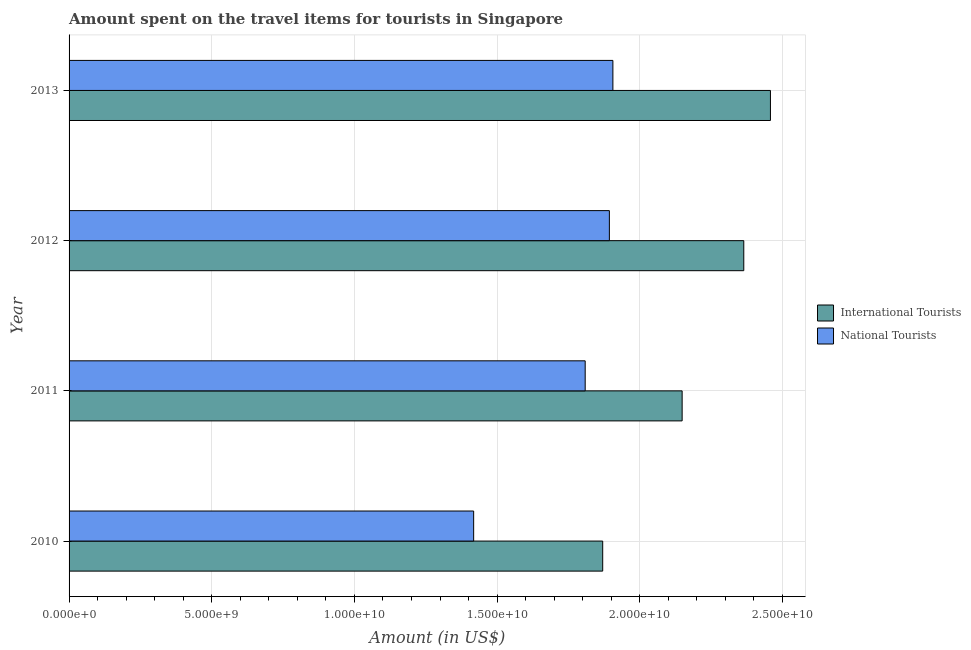How many different coloured bars are there?
Offer a very short reply. 2. How many groups of bars are there?
Offer a very short reply. 4. How many bars are there on the 1st tick from the top?
Ensure brevity in your answer.  2. How many bars are there on the 3rd tick from the bottom?
Give a very brief answer. 2. What is the label of the 2nd group of bars from the top?
Offer a terse response. 2012. What is the amount spent on travel items of international tourists in 2013?
Give a very brief answer. 2.46e+1. Across all years, what is the maximum amount spent on travel items of national tourists?
Your response must be concise. 1.91e+1. Across all years, what is the minimum amount spent on travel items of national tourists?
Ensure brevity in your answer.  1.42e+1. In which year was the amount spent on travel items of international tourists maximum?
Ensure brevity in your answer.  2013. In which year was the amount spent on travel items of international tourists minimum?
Provide a succinct answer. 2010. What is the total amount spent on travel items of national tourists in the graph?
Offer a terse response. 7.03e+1. What is the difference between the amount spent on travel items of national tourists in 2010 and that in 2011?
Keep it short and to the point. -3.91e+09. What is the difference between the amount spent on travel items of international tourists in 2012 and the amount spent on travel items of national tourists in 2010?
Your response must be concise. 9.47e+09. What is the average amount spent on travel items of international tourists per year?
Your response must be concise. 2.21e+1. In the year 2013, what is the difference between the amount spent on travel items of national tourists and amount spent on travel items of international tourists?
Provide a succinct answer. -5.52e+09. What is the ratio of the amount spent on travel items of national tourists in 2011 to that in 2012?
Offer a very short reply. 0.95. Is the amount spent on travel items of national tourists in 2010 less than that in 2013?
Your answer should be very brief. Yes. What is the difference between the highest and the second highest amount spent on travel items of national tourists?
Provide a short and direct response. 1.23e+08. What is the difference between the highest and the lowest amount spent on travel items of international tourists?
Provide a succinct answer. 5.88e+09. In how many years, is the amount spent on travel items of national tourists greater than the average amount spent on travel items of national tourists taken over all years?
Provide a succinct answer. 3. Is the sum of the amount spent on travel items of international tourists in 2010 and 2011 greater than the maximum amount spent on travel items of national tourists across all years?
Offer a very short reply. Yes. What does the 2nd bar from the top in 2010 represents?
Provide a short and direct response. International Tourists. What does the 1st bar from the bottom in 2011 represents?
Make the answer very short. International Tourists. How many years are there in the graph?
Provide a succinct answer. 4. Are the values on the major ticks of X-axis written in scientific E-notation?
Ensure brevity in your answer.  Yes. Does the graph contain any zero values?
Offer a terse response. No. Does the graph contain grids?
Offer a very short reply. Yes. How many legend labels are there?
Ensure brevity in your answer.  2. What is the title of the graph?
Ensure brevity in your answer.  Amount spent on the travel items for tourists in Singapore. Does "Under five" appear as one of the legend labels in the graph?
Make the answer very short. No. What is the label or title of the X-axis?
Offer a terse response. Amount (in US$). What is the label or title of the Y-axis?
Provide a succinct answer. Year. What is the Amount (in US$) of International Tourists in 2010?
Provide a succinct answer. 1.87e+1. What is the Amount (in US$) in National Tourists in 2010?
Your answer should be very brief. 1.42e+1. What is the Amount (in US$) of International Tourists in 2011?
Keep it short and to the point. 2.15e+1. What is the Amount (in US$) of National Tourists in 2011?
Provide a short and direct response. 1.81e+1. What is the Amount (in US$) in International Tourists in 2012?
Ensure brevity in your answer.  2.36e+1. What is the Amount (in US$) in National Tourists in 2012?
Give a very brief answer. 1.89e+1. What is the Amount (in US$) of International Tourists in 2013?
Keep it short and to the point. 2.46e+1. What is the Amount (in US$) of National Tourists in 2013?
Offer a very short reply. 1.91e+1. Across all years, what is the maximum Amount (in US$) of International Tourists?
Offer a terse response. 2.46e+1. Across all years, what is the maximum Amount (in US$) in National Tourists?
Provide a short and direct response. 1.91e+1. Across all years, what is the minimum Amount (in US$) in International Tourists?
Make the answer very short. 1.87e+1. Across all years, what is the minimum Amount (in US$) in National Tourists?
Provide a short and direct response. 1.42e+1. What is the total Amount (in US$) in International Tourists in the graph?
Your answer should be compact. 8.84e+1. What is the total Amount (in US$) of National Tourists in the graph?
Your answer should be very brief. 7.03e+1. What is the difference between the Amount (in US$) of International Tourists in 2010 and that in 2011?
Your response must be concise. -2.78e+09. What is the difference between the Amount (in US$) of National Tourists in 2010 and that in 2011?
Your answer should be very brief. -3.91e+09. What is the difference between the Amount (in US$) in International Tourists in 2010 and that in 2012?
Offer a terse response. -4.94e+09. What is the difference between the Amount (in US$) in National Tourists in 2010 and that in 2012?
Ensure brevity in your answer.  -4.76e+09. What is the difference between the Amount (in US$) of International Tourists in 2010 and that in 2013?
Give a very brief answer. -5.88e+09. What is the difference between the Amount (in US$) of National Tourists in 2010 and that in 2013?
Your answer should be compact. -4.88e+09. What is the difference between the Amount (in US$) in International Tourists in 2011 and that in 2012?
Keep it short and to the point. -2.16e+09. What is the difference between the Amount (in US$) of National Tourists in 2011 and that in 2012?
Provide a short and direct response. -8.48e+08. What is the difference between the Amount (in US$) of International Tourists in 2011 and that in 2013?
Your answer should be very brief. -3.09e+09. What is the difference between the Amount (in US$) in National Tourists in 2011 and that in 2013?
Provide a short and direct response. -9.71e+08. What is the difference between the Amount (in US$) of International Tourists in 2012 and that in 2013?
Offer a very short reply. -9.34e+08. What is the difference between the Amount (in US$) of National Tourists in 2012 and that in 2013?
Your answer should be very brief. -1.23e+08. What is the difference between the Amount (in US$) in International Tourists in 2010 and the Amount (in US$) in National Tourists in 2011?
Offer a terse response. 6.14e+08. What is the difference between the Amount (in US$) in International Tourists in 2010 and the Amount (in US$) in National Tourists in 2012?
Ensure brevity in your answer.  -2.34e+08. What is the difference between the Amount (in US$) of International Tourists in 2010 and the Amount (in US$) of National Tourists in 2013?
Your response must be concise. -3.57e+08. What is the difference between the Amount (in US$) of International Tourists in 2011 and the Amount (in US$) of National Tourists in 2012?
Keep it short and to the point. 2.55e+09. What is the difference between the Amount (in US$) in International Tourists in 2011 and the Amount (in US$) in National Tourists in 2013?
Provide a short and direct response. 2.43e+09. What is the difference between the Amount (in US$) of International Tourists in 2012 and the Amount (in US$) of National Tourists in 2013?
Your answer should be very brief. 4.59e+09. What is the average Amount (in US$) in International Tourists per year?
Ensure brevity in your answer.  2.21e+1. What is the average Amount (in US$) in National Tourists per year?
Give a very brief answer. 1.76e+1. In the year 2010, what is the difference between the Amount (in US$) of International Tourists and Amount (in US$) of National Tourists?
Provide a short and direct response. 4.52e+09. In the year 2011, what is the difference between the Amount (in US$) in International Tourists and Amount (in US$) in National Tourists?
Offer a very short reply. 3.40e+09. In the year 2012, what is the difference between the Amount (in US$) of International Tourists and Amount (in US$) of National Tourists?
Your answer should be very brief. 4.71e+09. In the year 2013, what is the difference between the Amount (in US$) of International Tourists and Amount (in US$) of National Tourists?
Your answer should be very brief. 5.52e+09. What is the ratio of the Amount (in US$) in International Tourists in 2010 to that in 2011?
Offer a terse response. 0.87. What is the ratio of the Amount (in US$) in National Tourists in 2010 to that in 2011?
Your answer should be compact. 0.78. What is the ratio of the Amount (in US$) of International Tourists in 2010 to that in 2012?
Provide a succinct answer. 0.79. What is the ratio of the Amount (in US$) of National Tourists in 2010 to that in 2012?
Give a very brief answer. 0.75. What is the ratio of the Amount (in US$) of International Tourists in 2010 to that in 2013?
Keep it short and to the point. 0.76. What is the ratio of the Amount (in US$) in National Tourists in 2010 to that in 2013?
Provide a succinct answer. 0.74. What is the ratio of the Amount (in US$) in International Tourists in 2011 to that in 2012?
Ensure brevity in your answer.  0.91. What is the ratio of the Amount (in US$) in National Tourists in 2011 to that in 2012?
Give a very brief answer. 0.96. What is the ratio of the Amount (in US$) of International Tourists in 2011 to that in 2013?
Offer a terse response. 0.87. What is the ratio of the Amount (in US$) of National Tourists in 2011 to that in 2013?
Your answer should be very brief. 0.95. What is the ratio of the Amount (in US$) in International Tourists in 2012 to that in 2013?
Your answer should be very brief. 0.96. What is the difference between the highest and the second highest Amount (in US$) of International Tourists?
Ensure brevity in your answer.  9.34e+08. What is the difference between the highest and the second highest Amount (in US$) of National Tourists?
Provide a short and direct response. 1.23e+08. What is the difference between the highest and the lowest Amount (in US$) in International Tourists?
Offer a terse response. 5.88e+09. What is the difference between the highest and the lowest Amount (in US$) in National Tourists?
Your answer should be compact. 4.88e+09. 